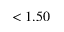<formula> <loc_0><loc_0><loc_500><loc_500>< 1 . 5 0</formula> 